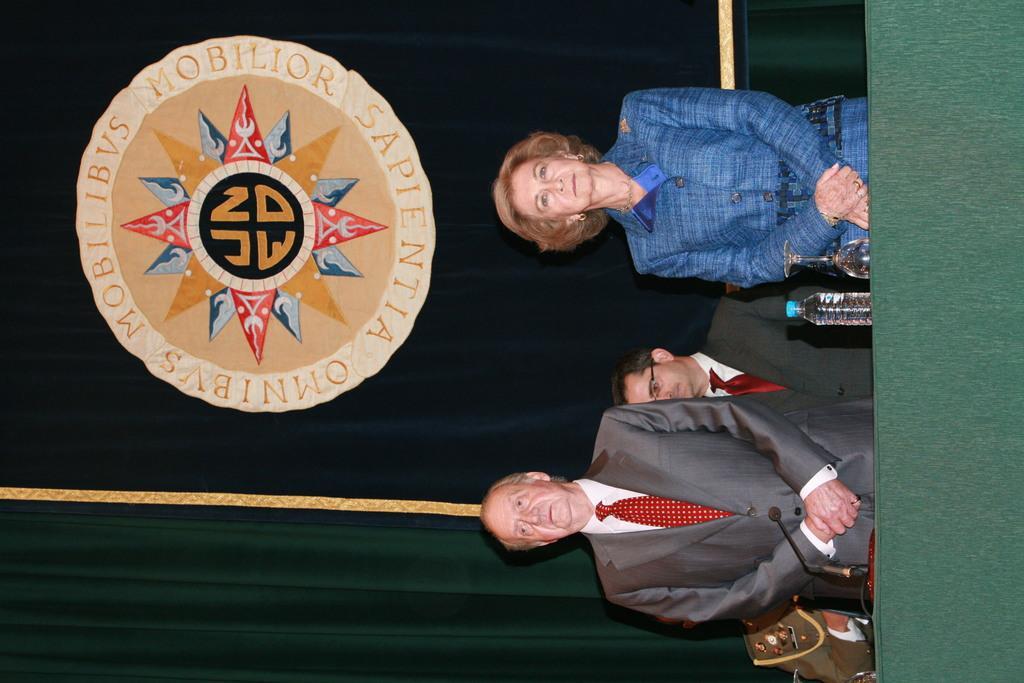How would you summarize this image in a sentence or two? In this image we can see persons standing on the floor and a table is placed in front of them. On the table there are glass tumbler, disposable bottle and a mic. In the background we can see a curtain with the emblem on it. 